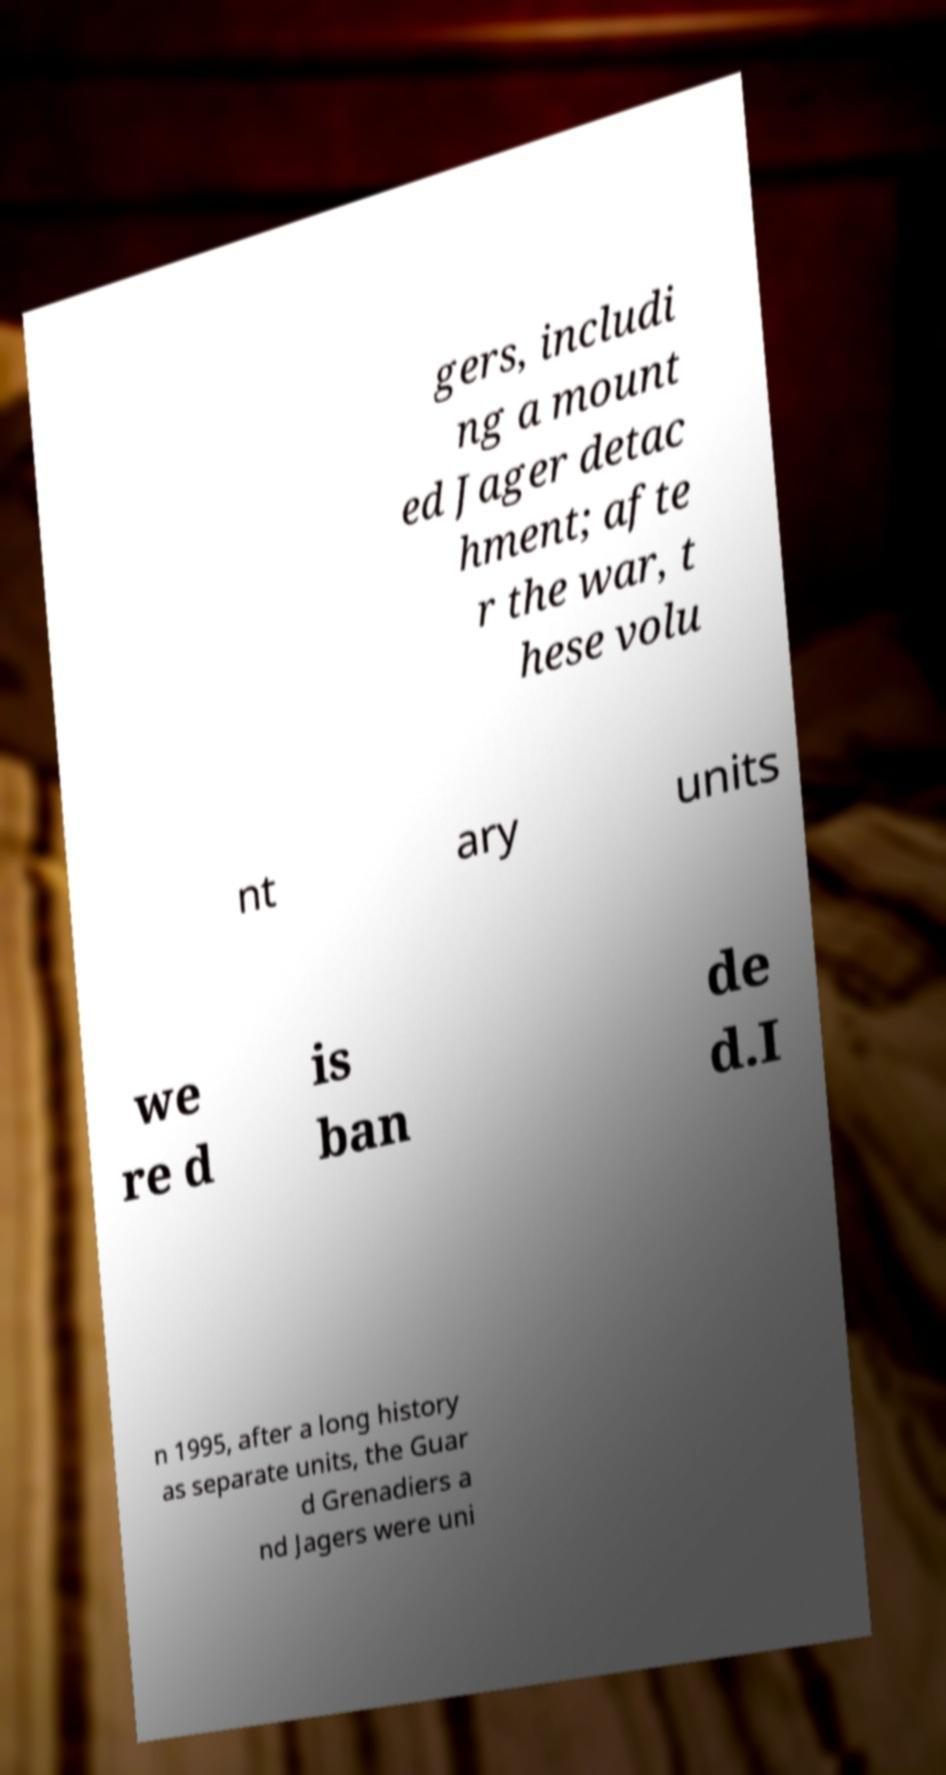I need the written content from this picture converted into text. Can you do that? gers, includi ng a mount ed Jager detac hment; afte r the war, t hese volu nt ary units we re d is ban de d.I n 1995, after a long history as separate units, the Guar d Grenadiers a nd Jagers were uni 